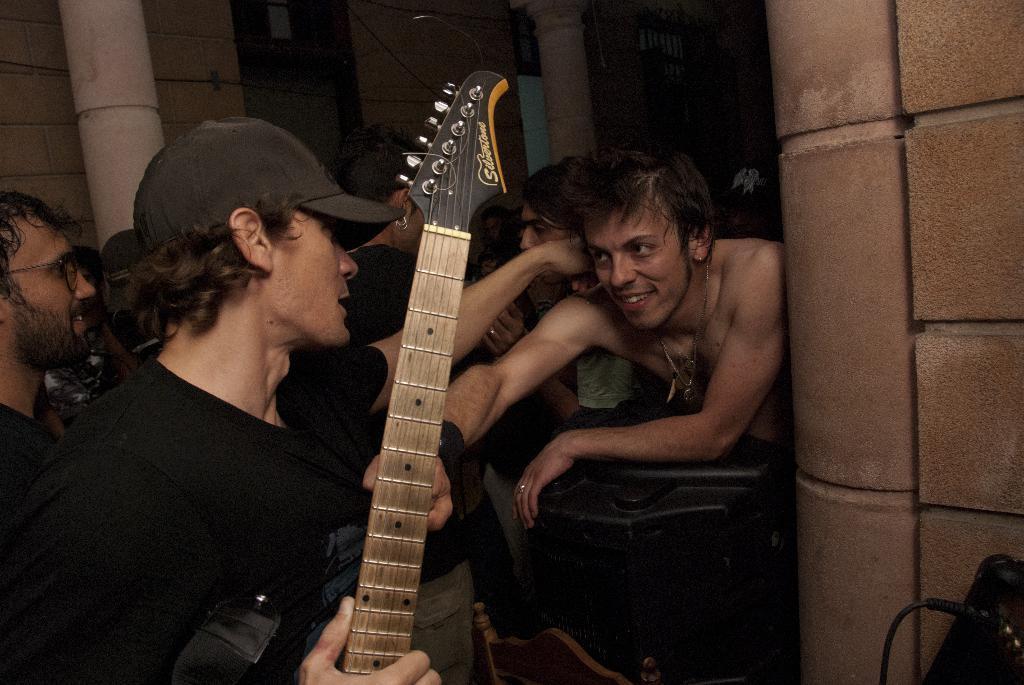Describe this image in one or two sentences. a person is standing holding a guitar. behind him there are other people. in the front there are people. the person at the front is holding the t shirt of a person in front of him. at the back there are pillars and a wall. 